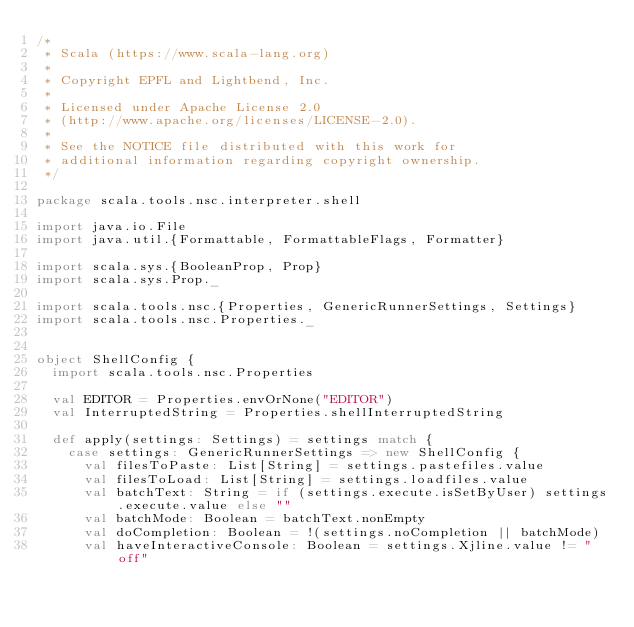<code> <loc_0><loc_0><loc_500><loc_500><_Scala_>/*
 * Scala (https://www.scala-lang.org)
 *
 * Copyright EPFL and Lightbend, Inc.
 *
 * Licensed under Apache License 2.0
 * (http://www.apache.org/licenses/LICENSE-2.0).
 *
 * See the NOTICE file distributed with this work for
 * additional information regarding copyright ownership.
 */

package scala.tools.nsc.interpreter.shell

import java.io.File
import java.util.{Formattable, FormattableFlags, Formatter}

import scala.sys.{BooleanProp, Prop}
import scala.sys.Prop._

import scala.tools.nsc.{Properties, GenericRunnerSettings, Settings}
import scala.tools.nsc.Properties._


object ShellConfig {
  import scala.tools.nsc.Properties

  val EDITOR = Properties.envOrNone("EDITOR")
  val InterruptedString = Properties.shellInterruptedString

  def apply(settings: Settings) = settings match {
    case settings: GenericRunnerSettings => new ShellConfig {
      val filesToPaste: List[String] = settings.pastefiles.value
      val filesToLoad: List[String] = settings.loadfiles.value
      val batchText: String = if (settings.execute.isSetByUser) settings.execute.value else ""
      val batchMode: Boolean = batchText.nonEmpty
      val doCompletion: Boolean = !(settings.noCompletion || batchMode)
      val haveInteractiveConsole: Boolean = settings.Xjline.value != "off"</code> 